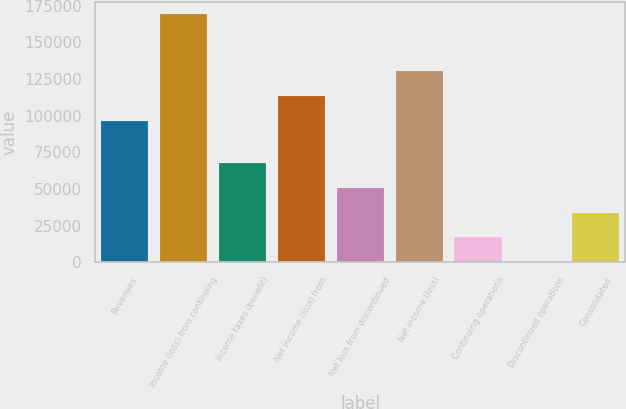Convert chart. <chart><loc_0><loc_0><loc_500><loc_500><bar_chart><fcel>Revenues<fcel>Income (loss) from continuing<fcel>Income taxes (benefit)<fcel>Net income (loss) from<fcel>Net loss from discontinued<fcel>Net income (loss)<fcel>Continuing operations<fcel>Discontinued operations<fcel>Consolidated<nl><fcel>96489<fcel>169269<fcel>67707.6<fcel>113416<fcel>50780.7<fcel>130343<fcel>16926.9<fcel>0.01<fcel>33853.8<nl></chart> 